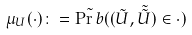Convert formula to latex. <formula><loc_0><loc_0><loc_500><loc_500>\mu _ { U } ( \cdot ) \colon = \tilde { \Pr b } ( ( \tilde { U } , \tilde { \tilde { U } } ) \in \cdot )</formula> 